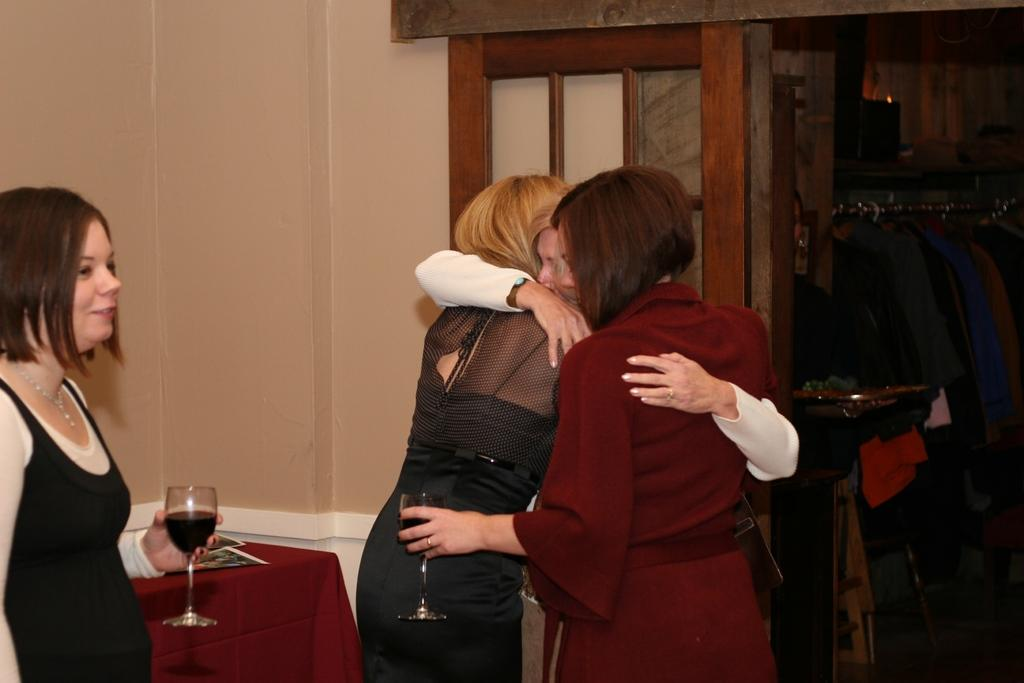What is the woman on the left side of the image doing? The woman on the left side of the image is standing. What is the woman holding in her hand? The woman is holding a white glass. How many women are walking together in the image? There are three women walking together in the image. Can you see a snail crawling on the woman's shoulder in the image? No, there is no snail present in the image. What type of payment method is being used by the women in the image? There is no payment method mentioned or depicted in the image. 